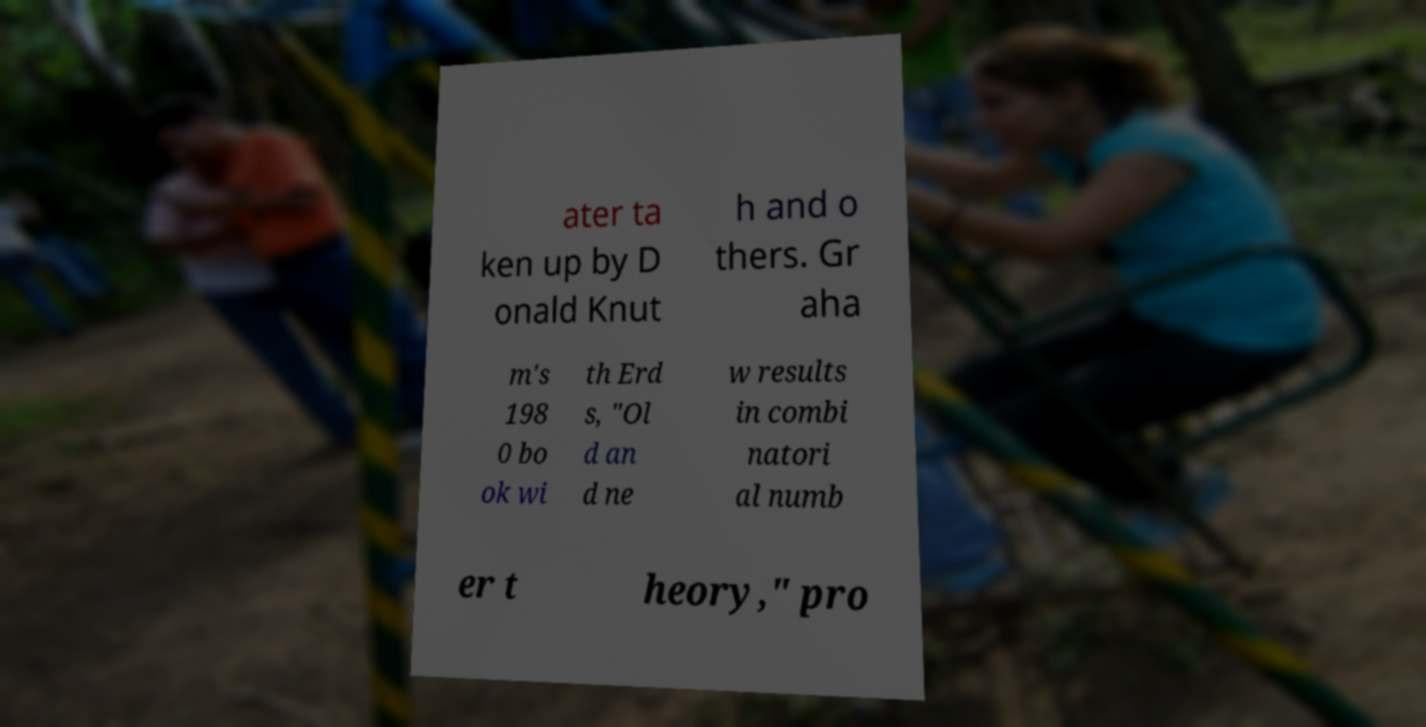There's text embedded in this image that I need extracted. Can you transcribe it verbatim? ater ta ken up by D onald Knut h and o thers. Gr aha m's 198 0 bo ok wi th Erd s, "Ol d an d ne w results in combi natori al numb er t heory," pro 